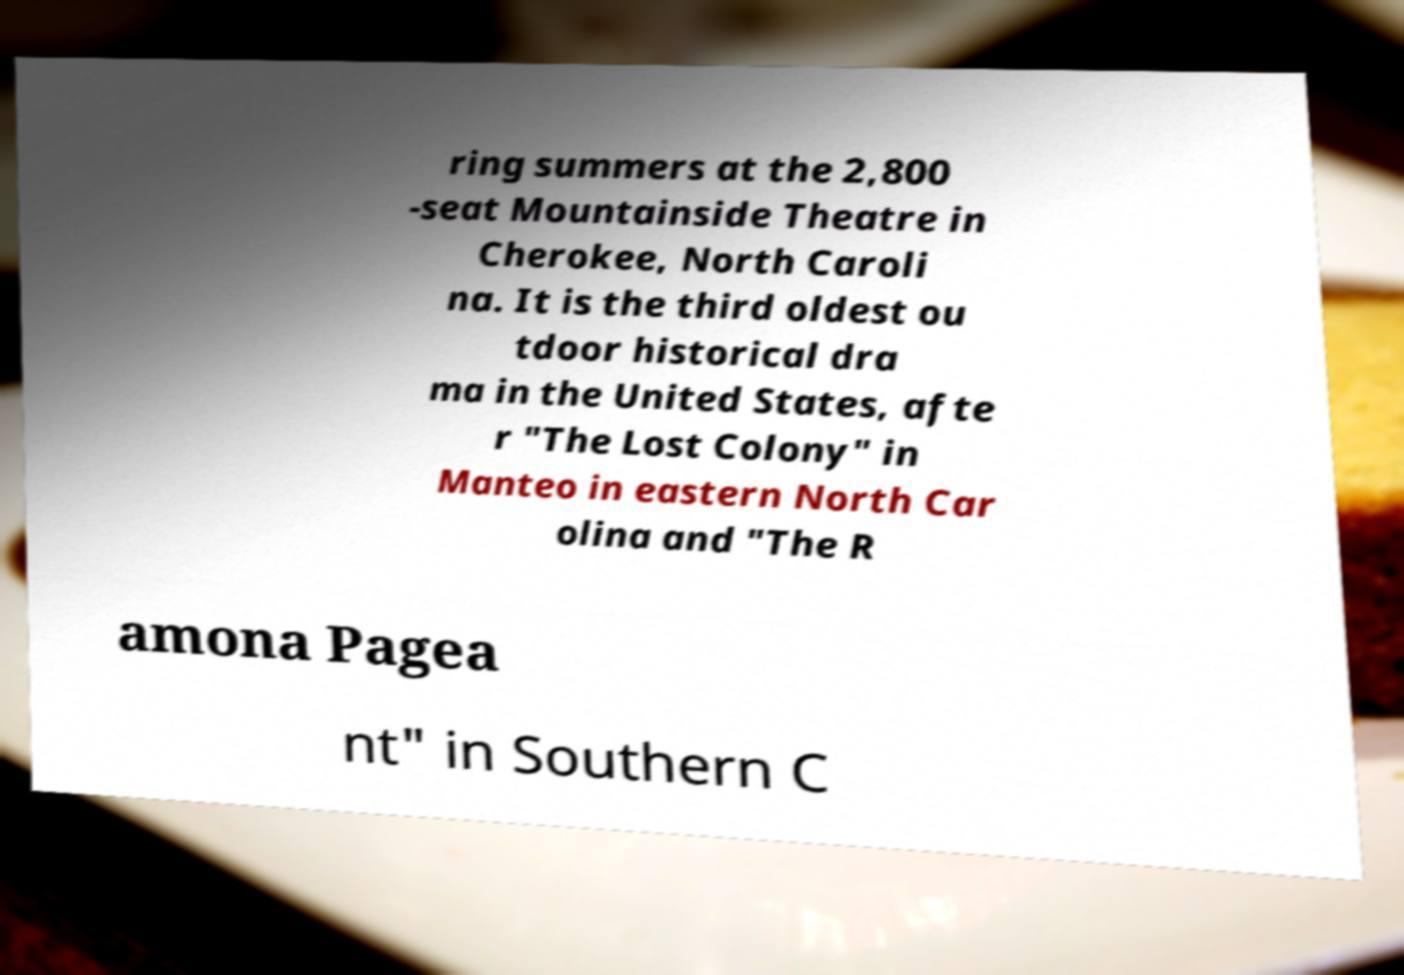What messages or text are displayed in this image? I need them in a readable, typed format. ring summers at the 2,800 -seat Mountainside Theatre in Cherokee, North Caroli na. It is the third oldest ou tdoor historical dra ma in the United States, afte r "The Lost Colony" in Manteo in eastern North Car olina and "The R amona Pagea nt" in Southern C 